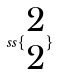<formula> <loc_0><loc_0><loc_500><loc_500>s s \{ \begin{matrix} 2 \\ 2 \end{matrix} \}</formula> 